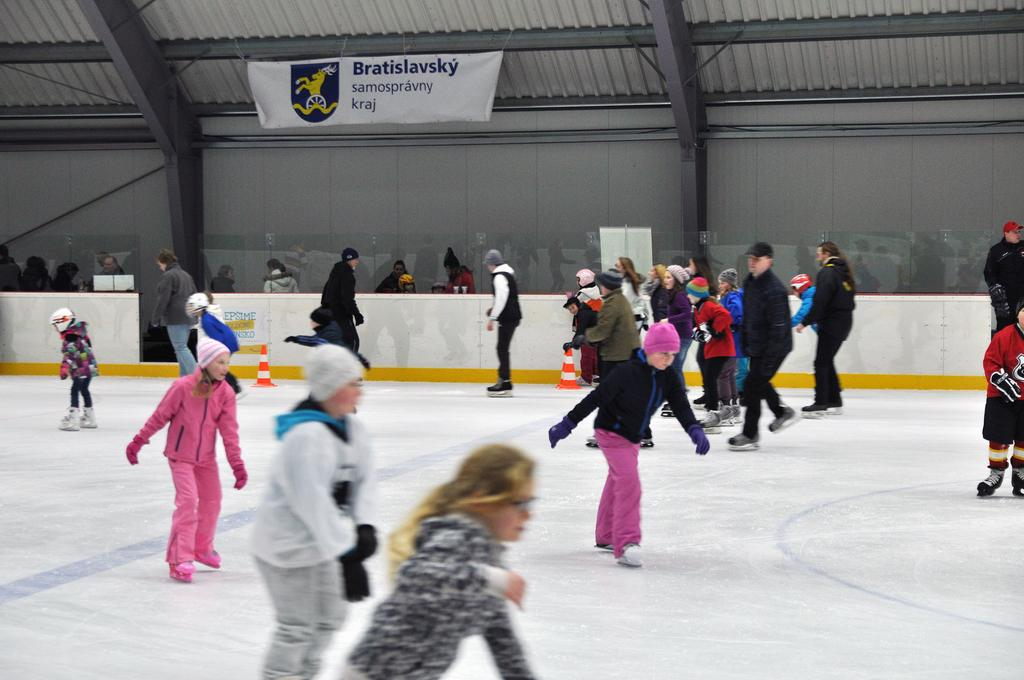What activity are the people in the image engaged in? The people in the image are ice skating. What type of clothing can be seen on some of the people? Some people are wearing caps and gloves. What is visible in the background of the image? There is a wall in the background, and a banner is on the wall. What objects are present on the ice? There are traffic cones in the image. What type of jeans are the people wearing in the image? There is no mention of jeans in the image, so we cannot determine what type of jeans the people are wearing. 